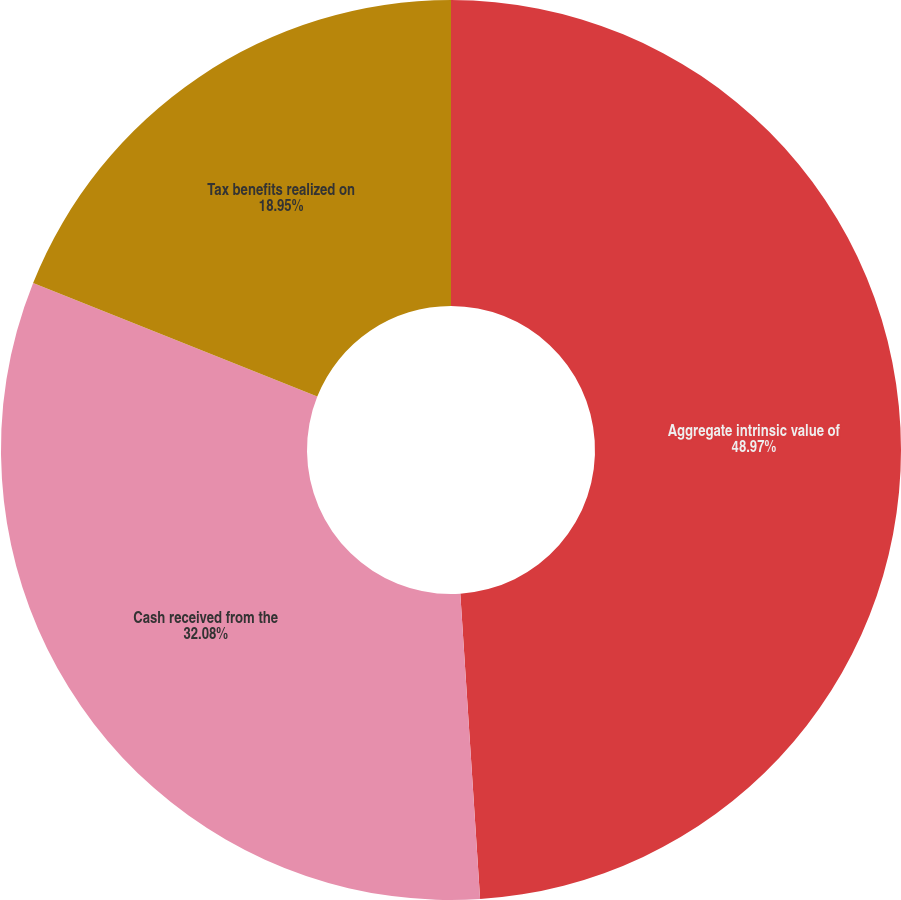Convert chart to OTSL. <chart><loc_0><loc_0><loc_500><loc_500><pie_chart><fcel>Aggregate intrinsic value of<fcel>Cash received from the<fcel>Tax benefits realized on<nl><fcel>48.97%<fcel>32.08%<fcel>18.95%<nl></chart> 